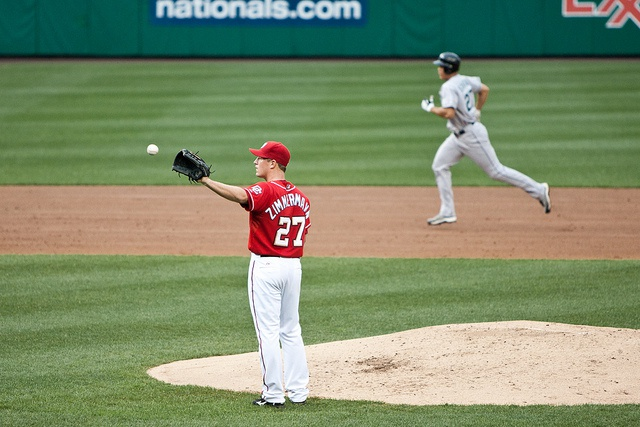Describe the objects in this image and their specific colors. I can see people in teal, white, brown, and black tones, people in teal, lightgray, darkgray, and gray tones, baseball glove in teal, black, gray, darkgray, and purple tones, and sports ball in teal, ivory, olive, lightgray, and darkgray tones in this image. 